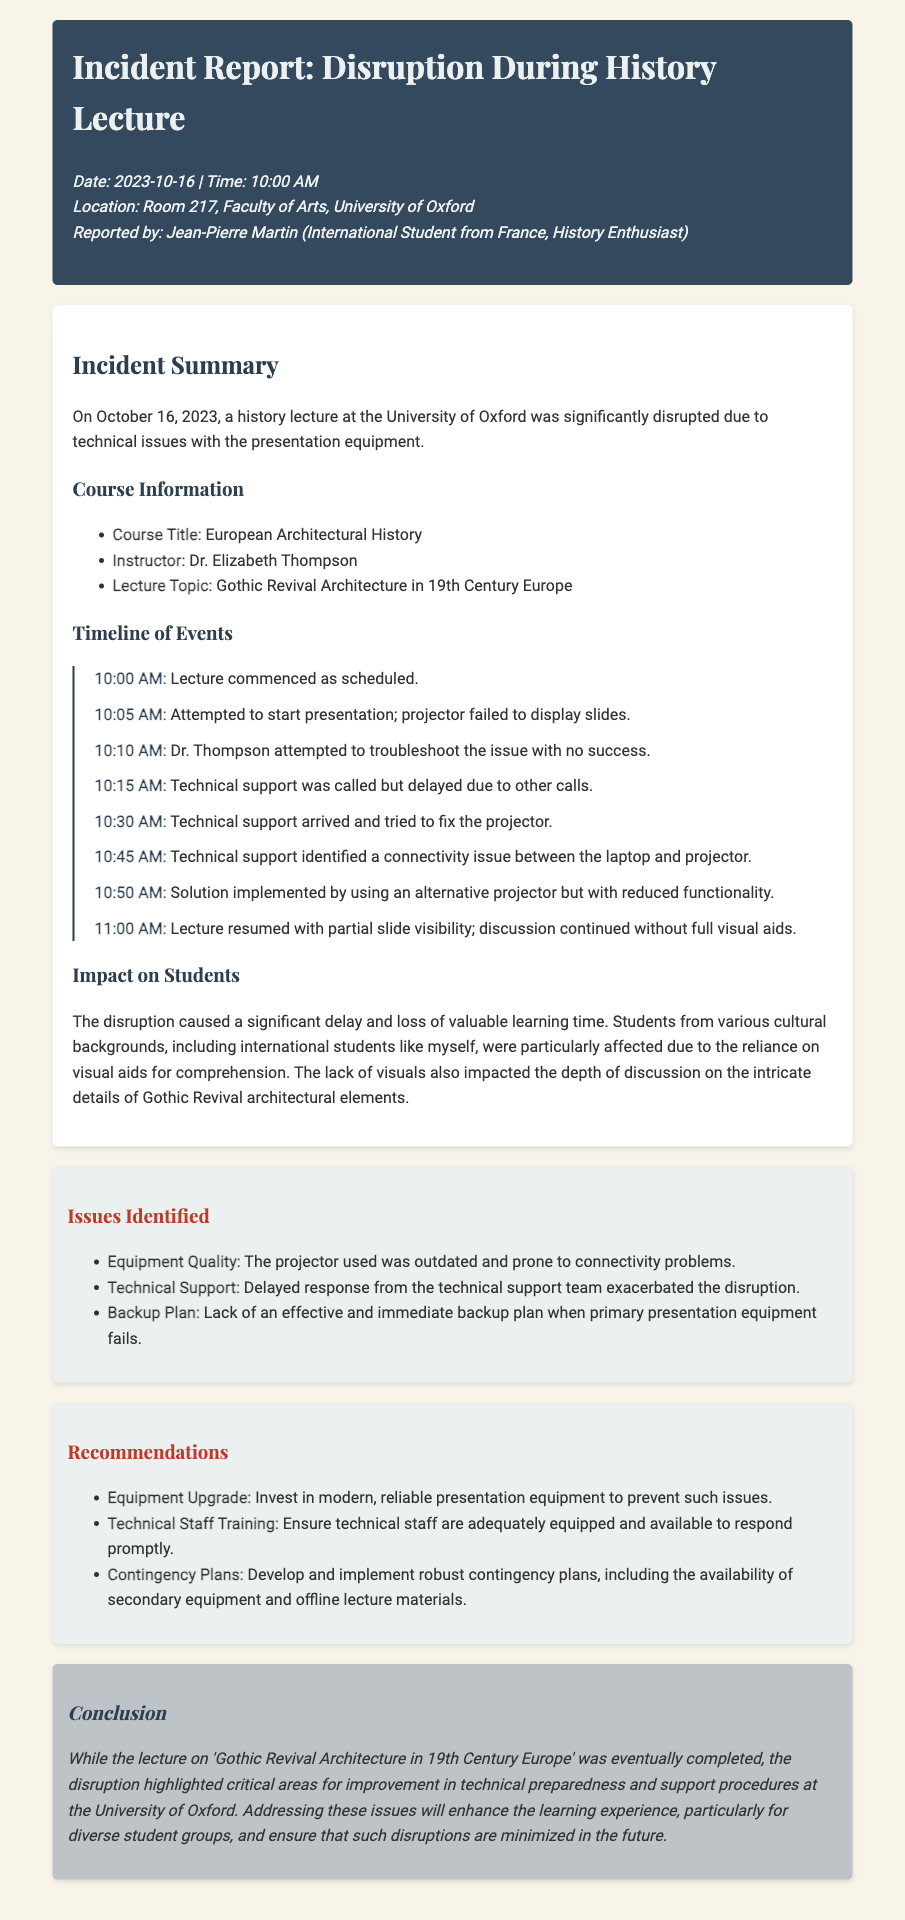what was the date of the incident? The incident occurred on October 16, 2023, as specified in the report.
Answer: October 16, 2023 who was the instructor for the lecture? The report mentions that the instructor for the lecture was Dr. Elizabeth Thompson.
Answer: Dr. Elizabeth Thompson what topic was covered in the lecture? The lecture topic specified in the document was Gothic Revival Architecture in 19th Century Europe.
Answer: Gothic Revival Architecture in 19th Century Europe what time did technical support arrive? The timeline notes that technical support arrived at 10:30 AM.
Answer: 10:30 AM what major issue led to the disruption? The disruption was primarily caused by a failure of the projector to display slides, as outlined in the timeline.
Answer: Projector failure how was the lecture resumed after the disruption? The lecture resumed using an alternative projector with reduced functionality, as mentioned in the incident report.
Answer: Alternative projector what recommendation involves the presentation equipment? One of the recommendations suggests investing in modern, reliable presentation equipment to prevent issues.
Answer: Equipment upgrade how did the disruption affect students? The report states that the disruption caused a significant delay and loss of valuable learning time for students.
Answer: Loss of valuable learning time what is one identified issue regarding technical support? The document notes that there was a delayed response from the technical support team, which exacerbated the disruption.
Answer: Delayed response 